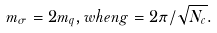Convert formula to latex. <formula><loc_0><loc_0><loc_500><loc_500>m _ { \sigma } = 2 m _ { q } , w h e n g = 2 \pi / \sqrt { N _ { c } } .</formula> 